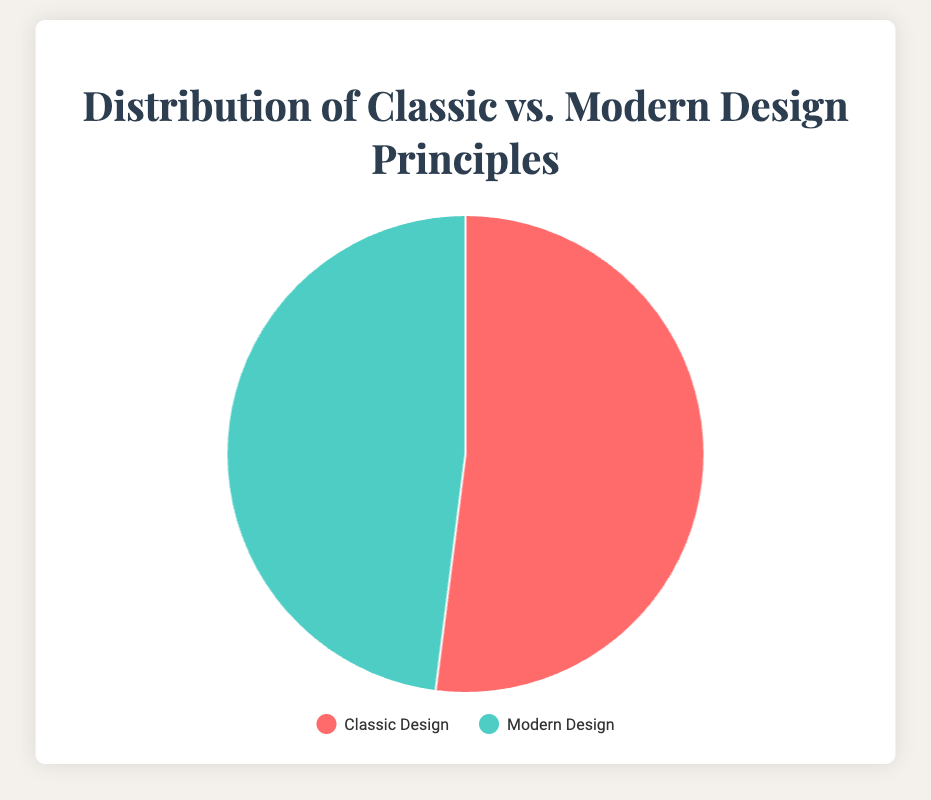What is the average percentage of classic design in the branding projects? To find the average percentage of classic design, we sum the classic design percentages (60 + 45 + 50 + 35 + 70) and divide by the number of projects (5). The sum is 260, and 260/5 equals 52.
Answer: 52 Which type of design principle, classic or modern, has a higher average percentage across all projects? The average percentage of classic design is 52, and the average percentage of modern design can be calculated similarly: (40 + 55 + 50 + 65 + 30)/5 = 48. Since 52 is greater than 48, classic design has a higher average percentage.
Answer: Classic What is the range of modern design percentages in the branding projects? To find the range, subtract the smallest percentage of modern design (30) from the largest (65). The calculation is 65 - 30, which equals 35.
Answer: 35 What percentage of modern design is used in the Urban Apparel project? The pie chart can show various distributions, but the given data indicate Urban Apparel uses 65% modern design.
Answer: 65 Which projects have a balanced distribution between classic and modern design? "Balanced" implies nearly equal percentages of classic and modern design. From the given projects, Eco Living Fair has 50% classic and 50% modern design.
Answer: Eco Living Fair What would be the combined percentage of modern design for Global Tech Summit and Vintage Market projects? To find the combined percentage, we add the modern design percentages of the two projects: 40 (Global Tech Summit) + 30 (Vintage Market). The combined percentage is 70.
Answer: 70 Is there a project where classic design completely dominates modern design? No project has a 100% classic design, but the closest is the Vintage Market project where classic design is 70% and modern is 30%.
Answer: No Comparing Artisan Coffee House and Global Tech Summit, which has a higher modern design percentage? Artisan Coffee House has a 55% modern design percentage, while Global Tech Summit has 40%. Therefore, Artisan Coffee House has a higher modern design percentage.
Answer: Artisan Coffee House What is the difference in the classic design percentage between Global Tech Summit and Urban Apparel? The classic design percentage for Global Tech Summit is 60, and for Urban Apparel, it is 35. The difference is 60 - 35, which equals 25.
Answer: 25 In which project is the classic design percentage closest to the average classic design percentage across all projects? The average classic design percentage is 52. The closest project to 52 is Eco Living Fair, with a classic design percentage of 50.
Answer: Eco Living Fair 